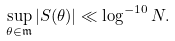Convert formula to latex. <formula><loc_0><loc_0><loc_500><loc_500>\sup _ { \theta \in \mathfrak { m } } | S ( \theta ) | \ll \log ^ { - 1 0 } N .</formula> 